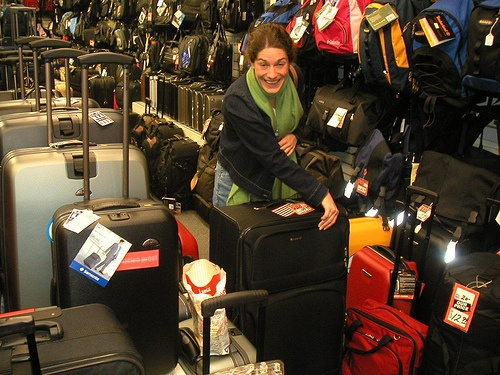Describe the objects in this image and their specific colors. I can see suitcase in maroon, black, ivory, and gray tones, suitcase in maroon, black, olive, and tan tones, suitcase in maroon, tan, darkgray, gray, and black tones, people in maroon, black, olive, and orange tones, and backpack in maroon, black, red, and tan tones in this image. 